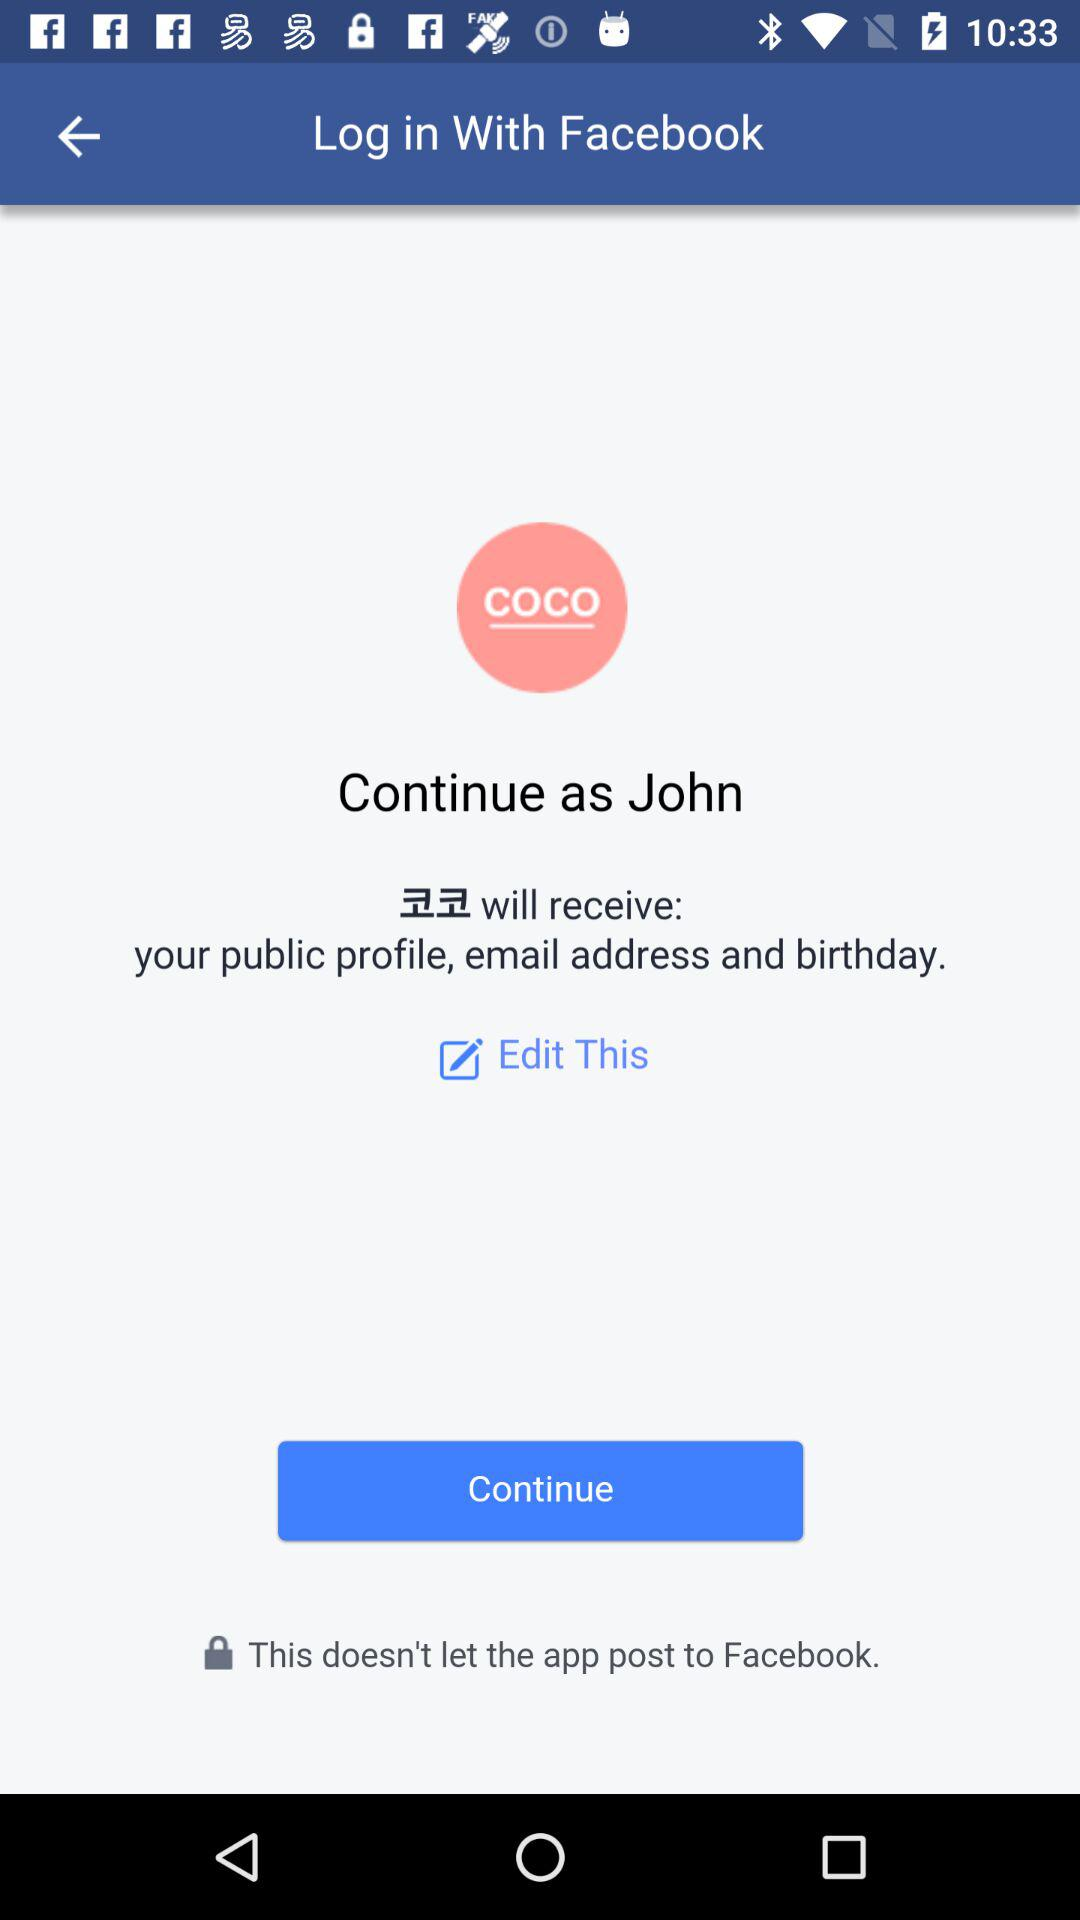What is the name of the user? The name of the user is "John". 